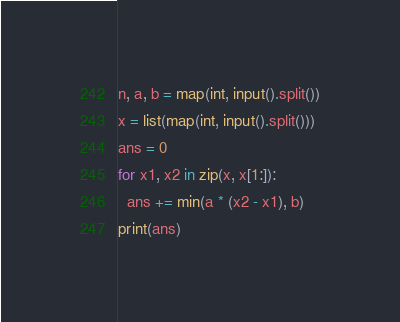Convert code to text. <code><loc_0><loc_0><loc_500><loc_500><_Python_>n, a, b = map(int, input().split())
x = list(map(int, input().split()))
ans = 0
for x1, x2 in zip(x, x[1:]):
  ans += min(a * (x2 - x1), b)
print(ans)</code> 